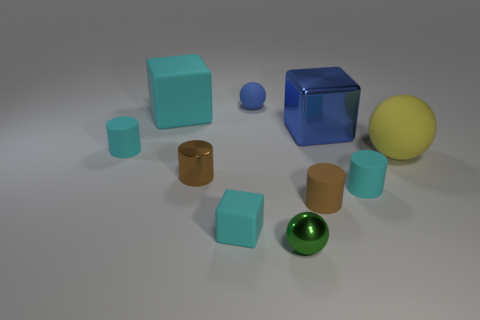Subtract all small balls. How many balls are left? 1 Subtract all brown cylinders. How many cylinders are left? 2 Subtract all cylinders. How many objects are left? 6 Subtract all blue balls. How many cyan cubes are left? 2 Add 1 small cyan objects. How many small cyan objects are left? 4 Add 3 small rubber balls. How many small rubber balls exist? 4 Subtract 0 cyan balls. How many objects are left? 10 Subtract 4 cylinders. How many cylinders are left? 0 Subtract all gray cubes. Subtract all gray balls. How many cubes are left? 3 Subtract all cubes. Subtract all tiny matte balls. How many objects are left? 6 